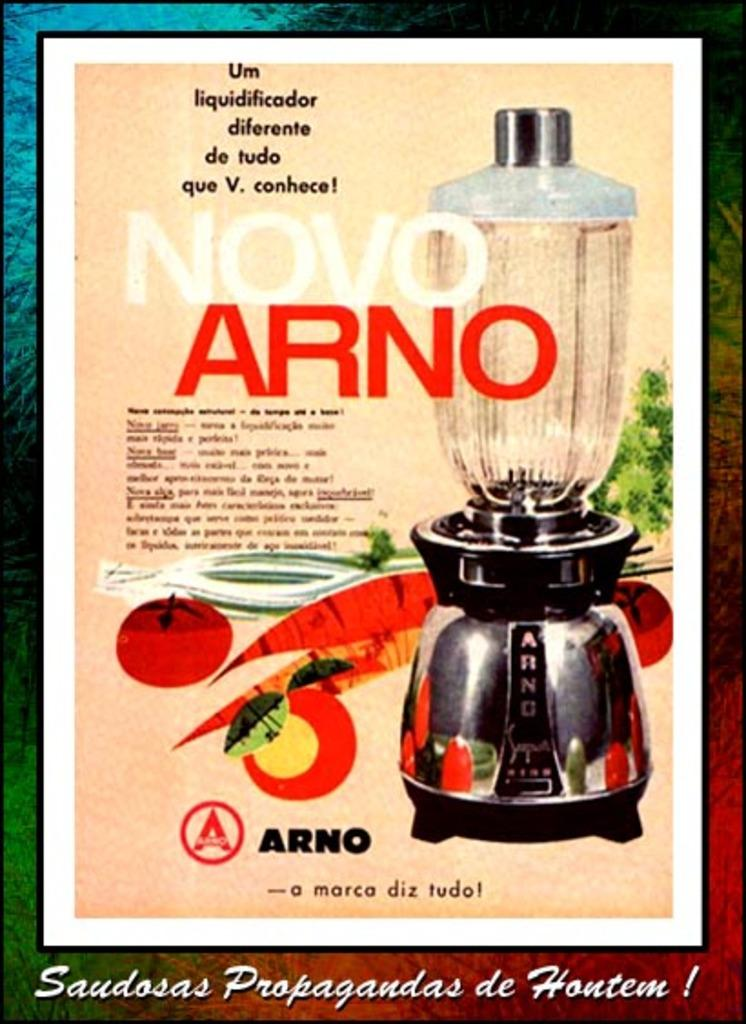<image>
Render a clear and concise summary of the photo. A poster in spanish for an Arino coffee maker. 